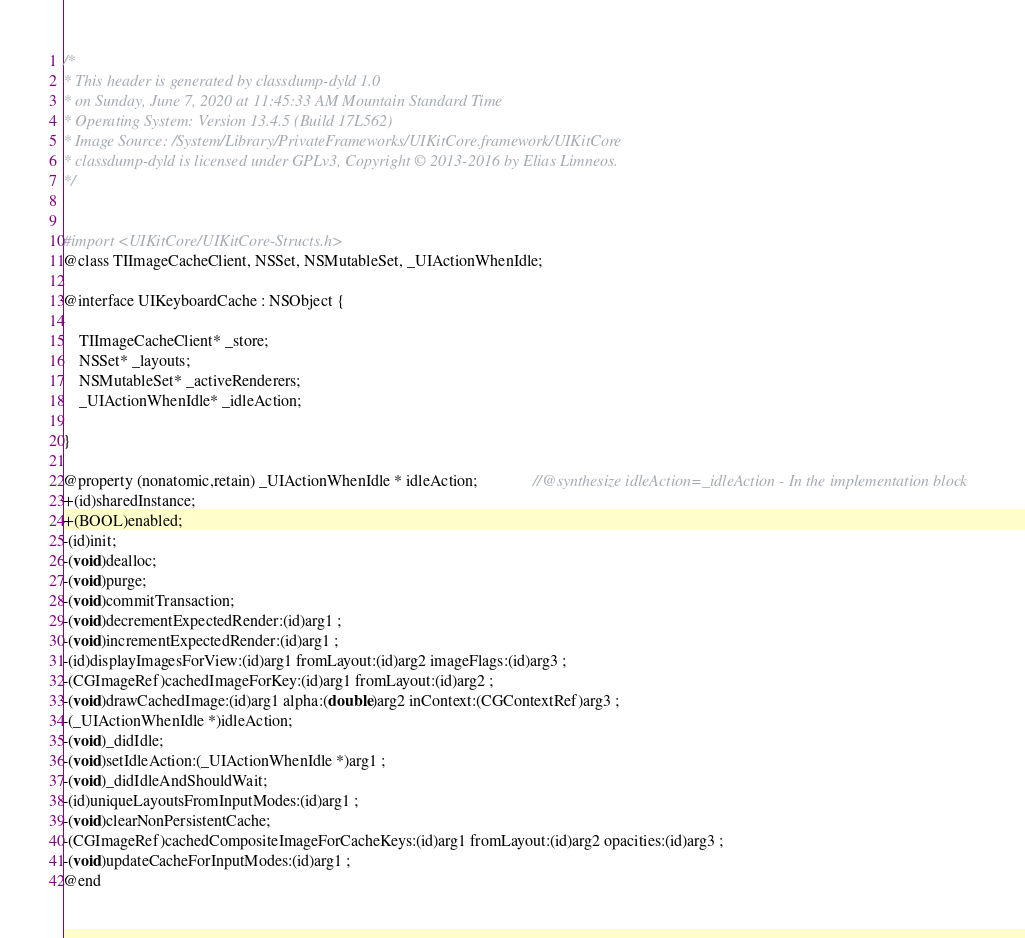<code> <loc_0><loc_0><loc_500><loc_500><_C_>/*
* This header is generated by classdump-dyld 1.0
* on Sunday, June 7, 2020 at 11:45:33 AM Mountain Standard Time
* Operating System: Version 13.4.5 (Build 17L562)
* Image Source: /System/Library/PrivateFrameworks/UIKitCore.framework/UIKitCore
* classdump-dyld is licensed under GPLv3, Copyright © 2013-2016 by Elias Limneos.
*/


#import <UIKitCore/UIKitCore-Structs.h>
@class TIImageCacheClient, NSSet, NSMutableSet, _UIActionWhenIdle;

@interface UIKeyboardCache : NSObject {

	TIImageCacheClient* _store;
	NSSet* _layouts;
	NSMutableSet* _activeRenderers;
	_UIActionWhenIdle* _idleAction;

}

@property (nonatomic,retain) _UIActionWhenIdle * idleAction;              //@synthesize idleAction=_idleAction - In the implementation block
+(id)sharedInstance;
+(BOOL)enabled;
-(id)init;
-(void)dealloc;
-(void)purge;
-(void)commitTransaction;
-(void)decrementExpectedRender:(id)arg1 ;
-(void)incrementExpectedRender:(id)arg1 ;
-(id)displayImagesForView:(id)arg1 fromLayout:(id)arg2 imageFlags:(id)arg3 ;
-(CGImageRef)cachedImageForKey:(id)arg1 fromLayout:(id)arg2 ;
-(void)drawCachedImage:(id)arg1 alpha:(double)arg2 inContext:(CGContextRef)arg3 ;
-(_UIActionWhenIdle *)idleAction;
-(void)_didIdle;
-(void)setIdleAction:(_UIActionWhenIdle *)arg1 ;
-(void)_didIdleAndShouldWait;
-(id)uniqueLayoutsFromInputModes:(id)arg1 ;
-(void)clearNonPersistentCache;
-(CGImageRef)cachedCompositeImageForCacheKeys:(id)arg1 fromLayout:(id)arg2 opacities:(id)arg3 ;
-(void)updateCacheForInputModes:(id)arg1 ;
@end

</code> 